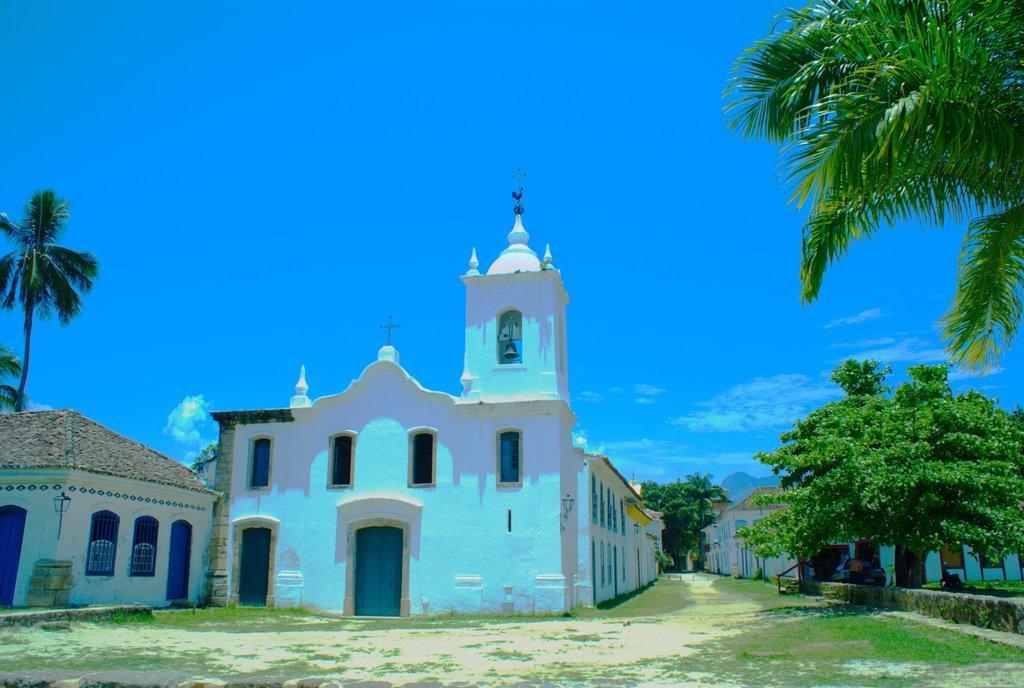In one or two sentences, can you explain what this image depicts? This is the picture of a place where we have some houses, trees, plants and some grass on the floor. 